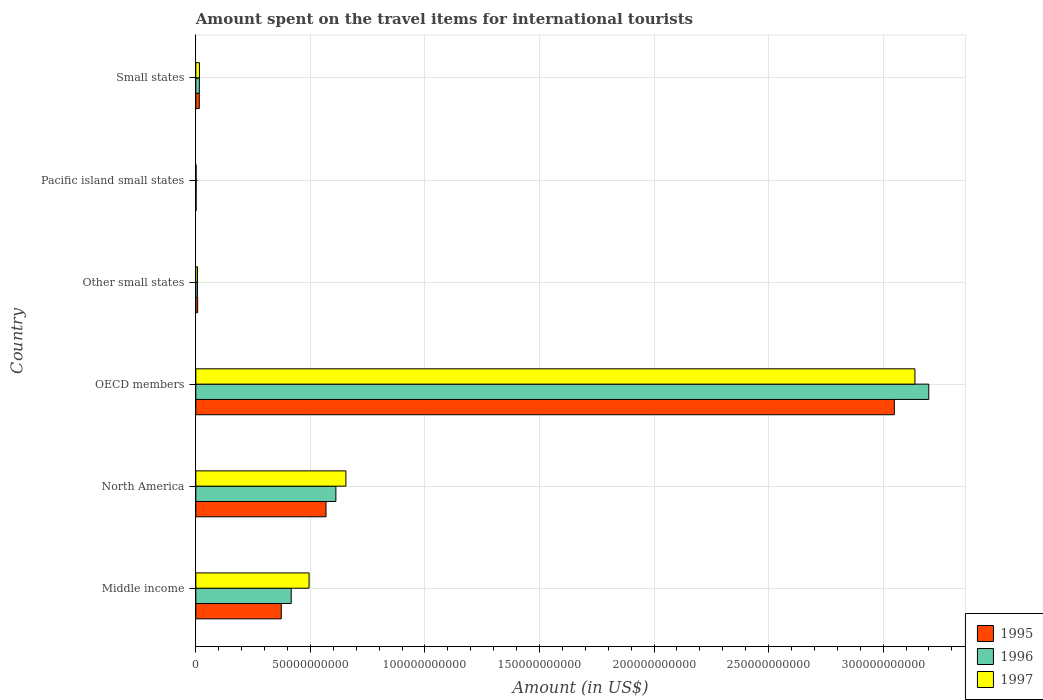How many different coloured bars are there?
Your answer should be very brief. 3. How many bars are there on the 2nd tick from the top?
Your response must be concise. 3. What is the label of the 2nd group of bars from the top?
Ensure brevity in your answer.  Pacific island small states. In how many cases, is the number of bars for a given country not equal to the number of legend labels?
Your response must be concise. 0. What is the amount spent on the travel items for international tourists in 1996 in Other small states?
Offer a very short reply. 7.07e+08. Across all countries, what is the maximum amount spent on the travel items for international tourists in 1996?
Keep it short and to the point. 3.20e+11. Across all countries, what is the minimum amount spent on the travel items for international tourists in 1995?
Offer a terse response. 1.10e+08. In which country was the amount spent on the travel items for international tourists in 1995 maximum?
Offer a terse response. OECD members. In which country was the amount spent on the travel items for international tourists in 1996 minimum?
Make the answer very short. Pacific island small states. What is the total amount spent on the travel items for international tourists in 1995 in the graph?
Offer a very short reply. 4.01e+11. What is the difference between the amount spent on the travel items for international tourists in 1995 in North America and that in Pacific island small states?
Make the answer very short. 5.67e+1. What is the difference between the amount spent on the travel items for international tourists in 1995 in North America and the amount spent on the travel items for international tourists in 1997 in Pacific island small states?
Keep it short and to the point. 5.67e+1. What is the average amount spent on the travel items for international tourists in 1996 per country?
Provide a short and direct response. 7.08e+1. What is the difference between the amount spent on the travel items for international tourists in 1995 and amount spent on the travel items for international tourists in 1997 in Small states?
Ensure brevity in your answer.  -7.24e+07. In how many countries, is the amount spent on the travel items for international tourists in 1997 greater than 200000000000 US$?
Ensure brevity in your answer.  1. What is the ratio of the amount spent on the travel items for international tourists in 1997 in OECD members to that in Pacific island small states?
Your answer should be compact. 2770.82. What is the difference between the highest and the second highest amount spent on the travel items for international tourists in 1997?
Your answer should be compact. 2.48e+11. What is the difference between the highest and the lowest amount spent on the travel items for international tourists in 1996?
Keep it short and to the point. 3.20e+11. In how many countries, is the amount spent on the travel items for international tourists in 1996 greater than the average amount spent on the travel items for international tourists in 1996 taken over all countries?
Keep it short and to the point. 1. What does the 3rd bar from the top in Other small states represents?
Give a very brief answer. 1995. What does the 3rd bar from the bottom in Pacific island small states represents?
Your answer should be very brief. 1997. How many bars are there?
Offer a terse response. 18. Are all the bars in the graph horizontal?
Your answer should be very brief. Yes. Does the graph contain any zero values?
Provide a short and direct response. No. Does the graph contain grids?
Provide a short and direct response. Yes. How are the legend labels stacked?
Give a very brief answer. Vertical. What is the title of the graph?
Your answer should be compact. Amount spent on the travel items for international tourists. Does "2006" appear as one of the legend labels in the graph?
Provide a succinct answer. No. What is the label or title of the Y-axis?
Ensure brevity in your answer.  Country. What is the Amount (in US$) of 1995 in Middle income?
Offer a very short reply. 3.73e+1. What is the Amount (in US$) in 1996 in Middle income?
Your answer should be very brief. 4.16e+1. What is the Amount (in US$) in 1997 in Middle income?
Your answer should be very brief. 4.94e+1. What is the Amount (in US$) of 1995 in North America?
Your answer should be very brief. 5.68e+1. What is the Amount (in US$) in 1996 in North America?
Provide a short and direct response. 6.11e+1. What is the Amount (in US$) of 1997 in North America?
Provide a short and direct response. 6.55e+1. What is the Amount (in US$) of 1995 in OECD members?
Keep it short and to the point. 3.05e+11. What is the Amount (in US$) of 1996 in OECD members?
Your answer should be very brief. 3.20e+11. What is the Amount (in US$) of 1997 in OECD members?
Give a very brief answer. 3.14e+11. What is the Amount (in US$) in 1995 in Other small states?
Provide a short and direct response. 7.98e+08. What is the Amount (in US$) in 1996 in Other small states?
Provide a short and direct response. 7.07e+08. What is the Amount (in US$) in 1997 in Other small states?
Your response must be concise. 7.11e+08. What is the Amount (in US$) in 1995 in Pacific island small states?
Keep it short and to the point. 1.10e+08. What is the Amount (in US$) in 1996 in Pacific island small states?
Give a very brief answer. 1.21e+08. What is the Amount (in US$) of 1997 in Pacific island small states?
Give a very brief answer. 1.13e+08. What is the Amount (in US$) in 1995 in Small states?
Your answer should be compact. 1.51e+09. What is the Amount (in US$) in 1996 in Small states?
Your response must be concise. 1.54e+09. What is the Amount (in US$) in 1997 in Small states?
Offer a terse response. 1.58e+09. Across all countries, what is the maximum Amount (in US$) in 1995?
Your response must be concise. 3.05e+11. Across all countries, what is the maximum Amount (in US$) in 1996?
Your answer should be compact. 3.20e+11. Across all countries, what is the maximum Amount (in US$) in 1997?
Give a very brief answer. 3.14e+11. Across all countries, what is the minimum Amount (in US$) in 1995?
Make the answer very short. 1.10e+08. Across all countries, what is the minimum Amount (in US$) in 1996?
Provide a succinct answer. 1.21e+08. Across all countries, what is the minimum Amount (in US$) of 1997?
Keep it short and to the point. 1.13e+08. What is the total Amount (in US$) in 1995 in the graph?
Provide a succinct answer. 4.01e+11. What is the total Amount (in US$) of 1996 in the graph?
Give a very brief answer. 4.25e+11. What is the total Amount (in US$) of 1997 in the graph?
Provide a succinct answer. 4.31e+11. What is the difference between the Amount (in US$) of 1995 in Middle income and that in North America?
Give a very brief answer. -1.95e+1. What is the difference between the Amount (in US$) of 1996 in Middle income and that in North America?
Your answer should be very brief. -1.95e+1. What is the difference between the Amount (in US$) of 1997 in Middle income and that in North America?
Provide a succinct answer. -1.61e+1. What is the difference between the Amount (in US$) of 1995 in Middle income and that in OECD members?
Your answer should be compact. -2.68e+11. What is the difference between the Amount (in US$) of 1996 in Middle income and that in OECD members?
Keep it short and to the point. -2.78e+11. What is the difference between the Amount (in US$) in 1997 in Middle income and that in OECD members?
Your answer should be compact. -2.64e+11. What is the difference between the Amount (in US$) in 1995 in Middle income and that in Other small states?
Provide a short and direct response. 3.65e+1. What is the difference between the Amount (in US$) in 1996 in Middle income and that in Other small states?
Your answer should be very brief. 4.09e+1. What is the difference between the Amount (in US$) of 1997 in Middle income and that in Other small states?
Make the answer very short. 4.87e+1. What is the difference between the Amount (in US$) in 1995 in Middle income and that in Pacific island small states?
Ensure brevity in your answer.  3.72e+1. What is the difference between the Amount (in US$) in 1996 in Middle income and that in Pacific island small states?
Ensure brevity in your answer.  4.15e+1. What is the difference between the Amount (in US$) of 1997 in Middle income and that in Pacific island small states?
Provide a succinct answer. 4.93e+1. What is the difference between the Amount (in US$) in 1995 in Middle income and that in Small states?
Keep it short and to the point. 3.58e+1. What is the difference between the Amount (in US$) of 1996 in Middle income and that in Small states?
Offer a terse response. 4.01e+1. What is the difference between the Amount (in US$) of 1997 in Middle income and that in Small states?
Provide a succinct answer. 4.78e+1. What is the difference between the Amount (in US$) of 1995 in North America and that in OECD members?
Provide a succinct answer. -2.48e+11. What is the difference between the Amount (in US$) in 1996 in North America and that in OECD members?
Give a very brief answer. -2.59e+11. What is the difference between the Amount (in US$) in 1997 in North America and that in OECD members?
Ensure brevity in your answer.  -2.48e+11. What is the difference between the Amount (in US$) in 1995 in North America and that in Other small states?
Your answer should be very brief. 5.60e+1. What is the difference between the Amount (in US$) in 1996 in North America and that in Other small states?
Your answer should be compact. 6.04e+1. What is the difference between the Amount (in US$) of 1997 in North America and that in Other small states?
Offer a very short reply. 6.48e+1. What is the difference between the Amount (in US$) in 1995 in North America and that in Pacific island small states?
Provide a succinct answer. 5.67e+1. What is the difference between the Amount (in US$) in 1996 in North America and that in Pacific island small states?
Offer a very short reply. 6.10e+1. What is the difference between the Amount (in US$) in 1997 in North America and that in Pacific island small states?
Offer a very short reply. 6.54e+1. What is the difference between the Amount (in US$) of 1995 in North America and that in Small states?
Give a very brief answer. 5.53e+1. What is the difference between the Amount (in US$) in 1996 in North America and that in Small states?
Offer a very short reply. 5.96e+1. What is the difference between the Amount (in US$) of 1997 in North America and that in Small states?
Give a very brief answer. 6.39e+1. What is the difference between the Amount (in US$) in 1995 in OECD members and that in Other small states?
Offer a very short reply. 3.04e+11. What is the difference between the Amount (in US$) in 1996 in OECD members and that in Other small states?
Ensure brevity in your answer.  3.19e+11. What is the difference between the Amount (in US$) of 1997 in OECD members and that in Other small states?
Your answer should be very brief. 3.13e+11. What is the difference between the Amount (in US$) in 1995 in OECD members and that in Pacific island small states?
Keep it short and to the point. 3.05e+11. What is the difference between the Amount (in US$) in 1996 in OECD members and that in Pacific island small states?
Offer a terse response. 3.20e+11. What is the difference between the Amount (in US$) of 1997 in OECD members and that in Pacific island small states?
Your answer should be very brief. 3.14e+11. What is the difference between the Amount (in US$) in 1995 in OECD members and that in Small states?
Offer a terse response. 3.03e+11. What is the difference between the Amount (in US$) of 1996 in OECD members and that in Small states?
Give a very brief answer. 3.18e+11. What is the difference between the Amount (in US$) in 1997 in OECD members and that in Small states?
Make the answer very short. 3.12e+11. What is the difference between the Amount (in US$) of 1995 in Other small states and that in Pacific island small states?
Your response must be concise. 6.88e+08. What is the difference between the Amount (in US$) in 1996 in Other small states and that in Pacific island small states?
Offer a very short reply. 5.86e+08. What is the difference between the Amount (in US$) of 1997 in Other small states and that in Pacific island small states?
Ensure brevity in your answer.  5.98e+08. What is the difference between the Amount (in US$) of 1995 in Other small states and that in Small states?
Provide a succinct answer. -7.13e+08. What is the difference between the Amount (in US$) of 1996 in Other small states and that in Small states?
Keep it short and to the point. -8.36e+08. What is the difference between the Amount (in US$) of 1997 in Other small states and that in Small states?
Your answer should be very brief. -8.72e+08. What is the difference between the Amount (in US$) of 1995 in Pacific island small states and that in Small states?
Your answer should be compact. -1.40e+09. What is the difference between the Amount (in US$) in 1996 in Pacific island small states and that in Small states?
Provide a succinct answer. -1.42e+09. What is the difference between the Amount (in US$) in 1997 in Pacific island small states and that in Small states?
Provide a succinct answer. -1.47e+09. What is the difference between the Amount (in US$) in 1995 in Middle income and the Amount (in US$) in 1996 in North America?
Your response must be concise. -2.38e+1. What is the difference between the Amount (in US$) in 1995 in Middle income and the Amount (in US$) in 1997 in North America?
Provide a short and direct response. -2.82e+1. What is the difference between the Amount (in US$) in 1996 in Middle income and the Amount (in US$) in 1997 in North America?
Offer a terse response. -2.39e+1. What is the difference between the Amount (in US$) in 1995 in Middle income and the Amount (in US$) in 1996 in OECD members?
Ensure brevity in your answer.  -2.83e+11. What is the difference between the Amount (in US$) in 1995 in Middle income and the Amount (in US$) in 1997 in OECD members?
Make the answer very short. -2.77e+11. What is the difference between the Amount (in US$) in 1996 in Middle income and the Amount (in US$) in 1997 in OECD members?
Offer a terse response. -2.72e+11. What is the difference between the Amount (in US$) in 1995 in Middle income and the Amount (in US$) in 1996 in Other small states?
Provide a short and direct response. 3.66e+1. What is the difference between the Amount (in US$) in 1995 in Middle income and the Amount (in US$) in 1997 in Other small states?
Your answer should be very brief. 3.66e+1. What is the difference between the Amount (in US$) in 1996 in Middle income and the Amount (in US$) in 1997 in Other small states?
Your answer should be very brief. 4.09e+1. What is the difference between the Amount (in US$) in 1995 in Middle income and the Amount (in US$) in 1996 in Pacific island small states?
Your answer should be compact. 3.72e+1. What is the difference between the Amount (in US$) in 1995 in Middle income and the Amount (in US$) in 1997 in Pacific island small states?
Make the answer very short. 3.72e+1. What is the difference between the Amount (in US$) in 1996 in Middle income and the Amount (in US$) in 1997 in Pacific island small states?
Provide a succinct answer. 4.15e+1. What is the difference between the Amount (in US$) of 1995 in Middle income and the Amount (in US$) of 1996 in Small states?
Make the answer very short. 3.58e+1. What is the difference between the Amount (in US$) in 1995 in Middle income and the Amount (in US$) in 1997 in Small states?
Your answer should be very brief. 3.57e+1. What is the difference between the Amount (in US$) of 1996 in Middle income and the Amount (in US$) of 1997 in Small states?
Offer a terse response. 4.00e+1. What is the difference between the Amount (in US$) in 1995 in North America and the Amount (in US$) in 1996 in OECD members?
Your answer should be compact. -2.63e+11. What is the difference between the Amount (in US$) of 1995 in North America and the Amount (in US$) of 1997 in OECD members?
Offer a terse response. -2.57e+11. What is the difference between the Amount (in US$) of 1996 in North America and the Amount (in US$) of 1997 in OECD members?
Provide a short and direct response. -2.53e+11. What is the difference between the Amount (in US$) of 1995 in North America and the Amount (in US$) of 1996 in Other small states?
Provide a short and direct response. 5.61e+1. What is the difference between the Amount (in US$) in 1995 in North America and the Amount (in US$) in 1997 in Other small states?
Offer a terse response. 5.61e+1. What is the difference between the Amount (in US$) in 1996 in North America and the Amount (in US$) in 1997 in Other small states?
Your answer should be very brief. 6.04e+1. What is the difference between the Amount (in US$) in 1995 in North America and the Amount (in US$) in 1996 in Pacific island small states?
Ensure brevity in your answer.  5.67e+1. What is the difference between the Amount (in US$) in 1995 in North America and the Amount (in US$) in 1997 in Pacific island small states?
Your response must be concise. 5.67e+1. What is the difference between the Amount (in US$) in 1996 in North America and the Amount (in US$) in 1997 in Pacific island small states?
Your answer should be compact. 6.10e+1. What is the difference between the Amount (in US$) in 1995 in North America and the Amount (in US$) in 1996 in Small states?
Your response must be concise. 5.53e+1. What is the difference between the Amount (in US$) of 1995 in North America and the Amount (in US$) of 1997 in Small states?
Ensure brevity in your answer.  5.52e+1. What is the difference between the Amount (in US$) of 1996 in North America and the Amount (in US$) of 1997 in Small states?
Your answer should be very brief. 5.95e+1. What is the difference between the Amount (in US$) of 1995 in OECD members and the Amount (in US$) of 1996 in Other small states?
Offer a terse response. 3.04e+11. What is the difference between the Amount (in US$) of 1995 in OECD members and the Amount (in US$) of 1997 in Other small states?
Provide a succinct answer. 3.04e+11. What is the difference between the Amount (in US$) of 1996 in OECD members and the Amount (in US$) of 1997 in Other small states?
Your answer should be compact. 3.19e+11. What is the difference between the Amount (in US$) in 1995 in OECD members and the Amount (in US$) in 1996 in Pacific island small states?
Provide a short and direct response. 3.05e+11. What is the difference between the Amount (in US$) of 1995 in OECD members and the Amount (in US$) of 1997 in Pacific island small states?
Offer a very short reply. 3.05e+11. What is the difference between the Amount (in US$) of 1996 in OECD members and the Amount (in US$) of 1997 in Pacific island small states?
Offer a terse response. 3.20e+11. What is the difference between the Amount (in US$) of 1995 in OECD members and the Amount (in US$) of 1996 in Small states?
Ensure brevity in your answer.  3.03e+11. What is the difference between the Amount (in US$) in 1995 in OECD members and the Amount (in US$) in 1997 in Small states?
Your response must be concise. 3.03e+11. What is the difference between the Amount (in US$) in 1996 in OECD members and the Amount (in US$) in 1997 in Small states?
Your answer should be very brief. 3.18e+11. What is the difference between the Amount (in US$) of 1995 in Other small states and the Amount (in US$) of 1996 in Pacific island small states?
Provide a short and direct response. 6.77e+08. What is the difference between the Amount (in US$) in 1995 in Other small states and the Amount (in US$) in 1997 in Pacific island small states?
Provide a succinct answer. 6.85e+08. What is the difference between the Amount (in US$) of 1996 in Other small states and the Amount (in US$) of 1997 in Pacific island small states?
Provide a short and direct response. 5.94e+08. What is the difference between the Amount (in US$) of 1995 in Other small states and the Amount (in US$) of 1996 in Small states?
Ensure brevity in your answer.  -7.45e+08. What is the difference between the Amount (in US$) of 1995 in Other small states and the Amount (in US$) of 1997 in Small states?
Give a very brief answer. -7.86e+08. What is the difference between the Amount (in US$) of 1996 in Other small states and the Amount (in US$) of 1997 in Small states?
Ensure brevity in your answer.  -8.76e+08. What is the difference between the Amount (in US$) in 1995 in Pacific island small states and the Amount (in US$) in 1996 in Small states?
Ensure brevity in your answer.  -1.43e+09. What is the difference between the Amount (in US$) in 1995 in Pacific island small states and the Amount (in US$) in 1997 in Small states?
Offer a very short reply. -1.47e+09. What is the difference between the Amount (in US$) in 1996 in Pacific island small states and the Amount (in US$) in 1997 in Small states?
Offer a very short reply. -1.46e+09. What is the average Amount (in US$) of 1995 per country?
Your response must be concise. 6.69e+1. What is the average Amount (in US$) in 1996 per country?
Provide a short and direct response. 7.08e+1. What is the average Amount (in US$) in 1997 per country?
Provide a short and direct response. 7.19e+1. What is the difference between the Amount (in US$) in 1995 and Amount (in US$) in 1996 in Middle income?
Give a very brief answer. -4.33e+09. What is the difference between the Amount (in US$) in 1995 and Amount (in US$) in 1997 in Middle income?
Make the answer very short. -1.21e+1. What is the difference between the Amount (in US$) of 1996 and Amount (in US$) of 1997 in Middle income?
Offer a very short reply. -7.79e+09. What is the difference between the Amount (in US$) in 1995 and Amount (in US$) in 1996 in North America?
Your response must be concise. -4.30e+09. What is the difference between the Amount (in US$) in 1995 and Amount (in US$) in 1997 in North America?
Offer a very short reply. -8.68e+09. What is the difference between the Amount (in US$) in 1996 and Amount (in US$) in 1997 in North America?
Make the answer very short. -4.38e+09. What is the difference between the Amount (in US$) in 1995 and Amount (in US$) in 1996 in OECD members?
Your response must be concise. -1.50e+1. What is the difference between the Amount (in US$) of 1995 and Amount (in US$) of 1997 in OECD members?
Make the answer very short. -8.99e+09. What is the difference between the Amount (in US$) in 1996 and Amount (in US$) in 1997 in OECD members?
Provide a short and direct response. 6.04e+09. What is the difference between the Amount (in US$) in 1995 and Amount (in US$) in 1996 in Other small states?
Provide a short and direct response. 9.08e+07. What is the difference between the Amount (in US$) of 1995 and Amount (in US$) of 1997 in Other small states?
Ensure brevity in your answer.  8.65e+07. What is the difference between the Amount (in US$) of 1996 and Amount (in US$) of 1997 in Other small states?
Provide a short and direct response. -4.32e+06. What is the difference between the Amount (in US$) of 1995 and Amount (in US$) of 1996 in Pacific island small states?
Offer a very short reply. -1.12e+07. What is the difference between the Amount (in US$) in 1995 and Amount (in US$) in 1997 in Pacific island small states?
Provide a succinct answer. -3.22e+06. What is the difference between the Amount (in US$) in 1996 and Amount (in US$) in 1997 in Pacific island small states?
Your answer should be compact. 7.98e+06. What is the difference between the Amount (in US$) in 1995 and Amount (in US$) in 1996 in Small states?
Your response must be concise. -3.15e+07. What is the difference between the Amount (in US$) in 1995 and Amount (in US$) in 1997 in Small states?
Your response must be concise. -7.24e+07. What is the difference between the Amount (in US$) in 1996 and Amount (in US$) in 1997 in Small states?
Ensure brevity in your answer.  -4.09e+07. What is the ratio of the Amount (in US$) in 1995 in Middle income to that in North America?
Provide a succinct answer. 0.66. What is the ratio of the Amount (in US$) of 1996 in Middle income to that in North America?
Provide a succinct answer. 0.68. What is the ratio of the Amount (in US$) in 1997 in Middle income to that in North America?
Your answer should be compact. 0.75. What is the ratio of the Amount (in US$) of 1995 in Middle income to that in OECD members?
Provide a succinct answer. 0.12. What is the ratio of the Amount (in US$) of 1996 in Middle income to that in OECD members?
Give a very brief answer. 0.13. What is the ratio of the Amount (in US$) of 1997 in Middle income to that in OECD members?
Ensure brevity in your answer.  0.16. What is the ratio of the Amount (in US$) in 1995 in Middle income to that in Other small states?
Make the answer very short. 46.76. What is the ratio of the Amount (in US$) in 1996 in Middle income to that in Other small states?
Your response must be concise. 58.88. What is the ratio of the Amount (in US$) of 1997 in Middle income to that in Other small states?
Provide a succinct answer. 69.47. What is the ratio of the Amount (in US$) of 1995 in Middle income to that in Pacific island small states?
Offer a terse response. 338.92. What is the ratio of the Amount (in US$) in 1996 in Middle income to that in Pacific island small states?
Provide a succinct answer. 343.3. What is the ratio of the Amount (in US$) in 1997 in Middle income to that in Pacific island small states?
Provide a short and direct response. 436.23. What is the ratio of the Amount (in US$) in 1995 in Middle income to that in Small states?
Provide a short and direct response. 24.69. What is the ratio of the Amount (in US$) of 1996 in Middle income to that in Small states?
Your answer should be very brief. 26.99. What is the ratio of the Amount (in US$) of 1997 in Middle income to that in Small states?
Your answer should be very brief. 31.21. What is the ratio of the Amount (in US$) of 1995 in North America to that in OECD members?
Keep it short and to the point. 0.19. What is the ratio of the Amount (in US$) of 1996 in North America to that in OECD members?
Provide a succinct answer. 0.19. What is the ratio of the Amount (in US$) in 1997 in North America to that in OECD members?
Your response must be concise. 0.21. What is the ratio of the Amount (in US$) in 1995 in North America to that in Other small states?
Provide a succinct answer. 71.23. What is the ratio of the Amount (in US$) in 1996 in North America to that in Other small states?
Your answer should be compact. 86.46. What is the ratio of the Amount (in US$) of 1997 in North America to that in Other small states?
Provide a succinct answer. 92.09. What is the ratio of the Amount (in US$) of 1995 in North America to that in Pacific island small states?
Provide a short and direct response. 516.31. What is the ratio of the Amount (in US$) in 1996 in North America to that in Pacific island small states?
Your answer should be very brief. 504.1. What is the ratio of the Amount (in US$) in 1997 in North America to that in Pacific island small states?
Your answer should be compact. 578.25. What is the ratio of the Amount (in US$) of 1995 in North America to that in Small states?
Give a very brief answer. 37.61. What is the ratio of the Amount (in US$) of 1996 in North America to that in Small states?
Make the answer very short. 39.63. What is the ratio of the Amount (in US$) of 1997 in North America to that in Small states?
Your answer should be compact. 41.37. What is the ratio of the Amount (in US$) of 1995 in OECD members to that in Other small states?
Your response must be concise. 382.16. What is the ratio of the Amount (in US$) of 1996 in OECD members to that in Other small states?
Offer a very short reply. 452.5. What is the ratio of the Amount (in US$) of 1997 in OECD members to that in Other small states?
Your answer should be compact. 441.25. What is the ratio of the Amount (in US$) of 1995 in OECD members to that in Pacific island small states?
Keep it short and to the point. 2770.17. What is the ratio of the Amount (in US$) of 1996 in OECD members to that in Pacific island small states?
Ensure brevity in your answer.  2638.28. What is the ratio of the Amount (in US$) in 1997 in OECD members to that in Pacific island small states?
Provide a succinct answer. 2770.82. What is the ratio of the Amount (in US$) of 1995 in OECD members to that in Small states?
Offer a terse response. 201.77. What is the ratio of the Amount (in US$) in 1996 in OECD members to that in Small states?
Provide a succinct answer. 207.39. What is the ratio of the Amount (in US$) in 1997 in OECD members to that in Small states?
Give a very brief answer. 198.22. What is the ratio of the Amount (in US$) in 1995 in Other small states to that in Pacific island small states?
Provide a short and direct response. 7.25. What is the ratio of the Amount (in US$) in 1996 in Other small states to that in Pacific island small states?
Your answer should be very brief. 5.83. What is the ratio of the Amount (in US$) of 1997 in Other small states to that in Pacific island small states?
Provide a short and direct response. 6.28. What is the ratio of the Amount (in US$) of 1995 in Other small states to that in Small states?
Offer a very short reply. 0.53. What is the ratio of the Amount (in US$) of 1996 in Other small states to that in Small states?
Make the answer very short. 0.46. What is the ratio of the Amount (in US$) in 1997 in Other small states to that in Small states?
Ensure brevity in your answer.  0.45. What is the ratio of the Amount (in US$) of 1995 in Pacific island small states to that in Small states?
Give a very brief answer. 0.07. What is the ratio of the Amount (in US$) in 1996 in Pacific island small states to that in Small states?
Offer a terse response. 0.08. What is the ratio of the Amount (in US$) in 1997 in Pacific island small states to that in Small states?
Your answer should be compact. 0.07. What is the difference between the highest and the second highest Amount (in US$) of 1995?
Provide a succinct answer. 2.48e+11. What is the difference between the highest and the second highest Amount (in US$) in 1996?
Make the answer very short. 2.59e+11. What is the difference between the highest and the second highest Amount (in US$) in 1997?
Offer a very short reply. 2.48e+11. What is the difference between the highest and the lowest Amount (in US$) in 1995?
Your response must be concise. 3.05e+11. What is the difference between the highest and the lowest Amount (in US$) in 1996?
Make the answer very short. 3.20e+11. What is the difference between the highest and the lowest Amount (in US$) of 1997?
Provide a succinct answer. 3.14e+11. 